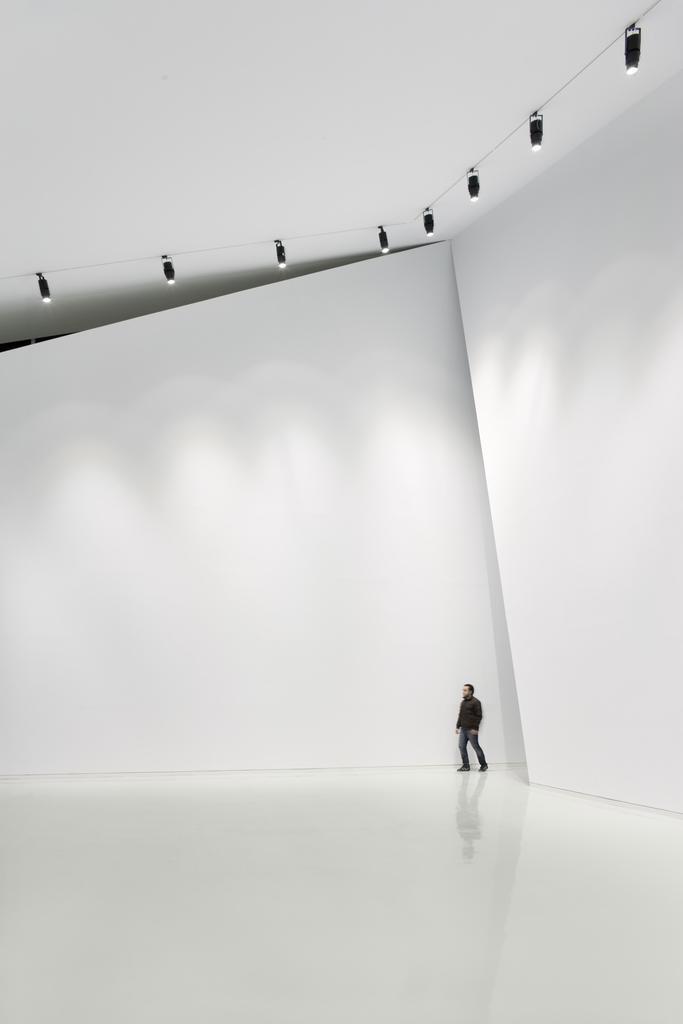Could you give a brief overview of what you see in this image? This is an inside picture of an auditorium. A human is standing in a black jacket and a jeans. Around him there is a white background. The floor is in white and the wall is in white color. 